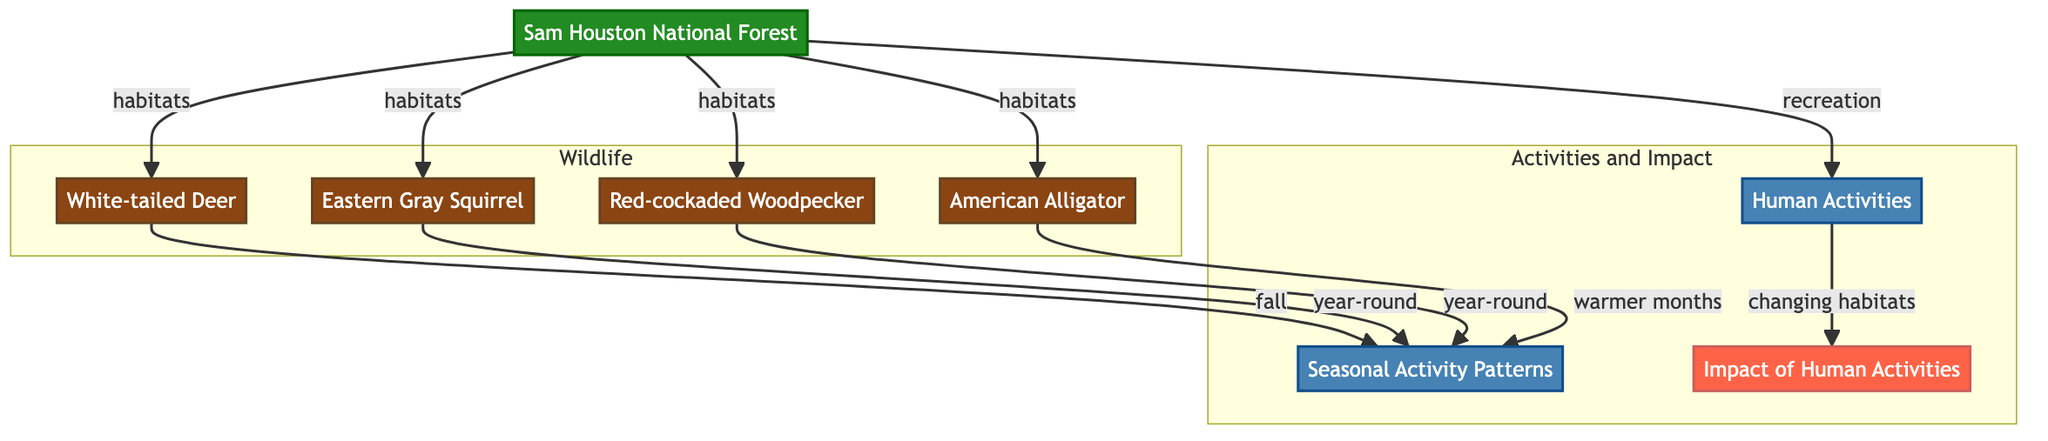What is the primary habitat for the animals listed in the diagram? The diagram indicates that all listed animals (White-tailed Deer, Eastern Gray Squirrel, Red-cockaded Woodpecker, American Alligator) are habitats found in Sam Houston National Forest. Thus, the primary habitat for these animals is the forest itself.
Answer: Sam Houston National Forest Which animal is associated with seasonal activity in the fall? The diagram specifies that the White-tailed Deer is the animal linked to seasonal activity patterns, specifically in the fall.
Answer: White-tailed Deer How many animal species are represented in the diagram? Counting the nodes in the 'Wildlife' subgraph shows there are four distinct animals: White-tailed Deer, Eastern Gray Squirrel, Red-cockaded Woodpecker, and American Alligator. Therefore, the total number of animal species is four.
Answer: 4 What activity is indicated to cause changes in habitats? The diagram shows that 'Human Activities' leads to 'Impact of Human Activities,' which implies that human activities are responsible for changing habitats. Thus, the activity causing these changes is Human Activities.
Answer: Human Activities Which animal in the diagram is active year-round? The diagram mentions that both the Eastern Gray Squirrel and the Red-cockaded Woodpecker are recognized as active year-round, thus identifying them as the animals with consistent activity throughout the year.
Answer: Eastern Gray Squirrel and Red-cockaded Woodpecker What is one impact of human activities mentioned in the diagram? The diagram directly connects 'Human Activities' to 'Impact of Human Activities,' suggesting that one consequence is changes in habitats caused by human impact.
Answer: Changing habitats During which months is the American Alligator active? According to the diagram, the American Alligator is noted to be active during warmer months, indicating a specific period of activity that corresponds to seasonal temperature changes.
Answer: Warmer months What leads to seasonal activity patterns for the animals listed? The diagram establishes a direct relationship where various animals such as the White-tailed Deer are associated with seasonal activity patterns, indicating ecological and behavioral responses to seasonal changes.
Answer: Habitats and animal behavior 